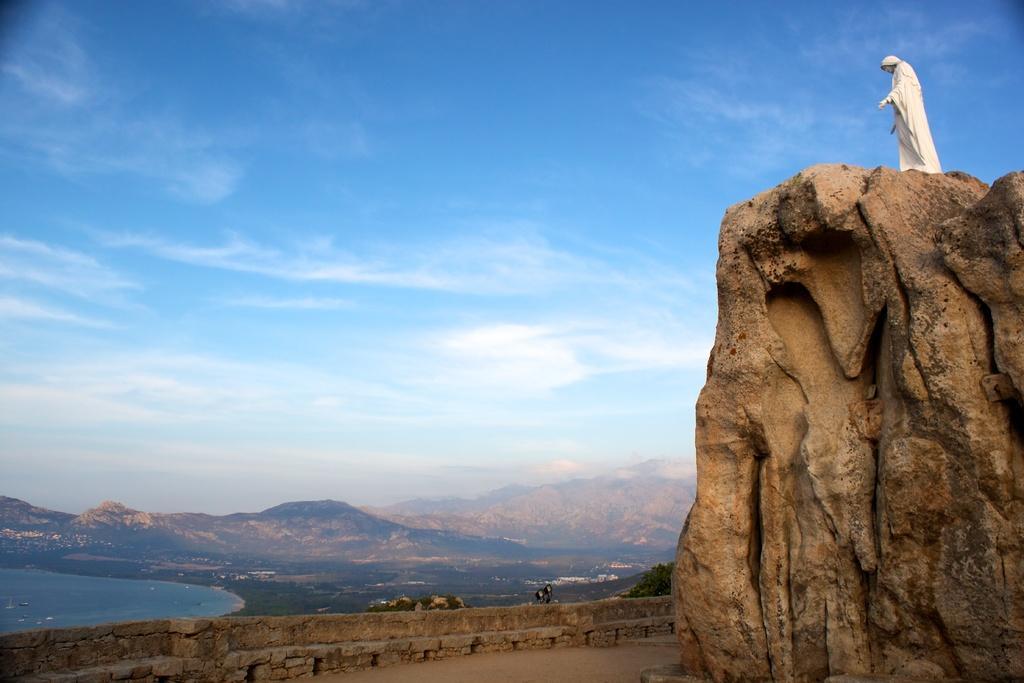Please provide a concise description of this image. In this picture we can see a statue, here we can see rocks, ground, beside this ground we can see a wall, trees and some objects and in the background we can see water and sky with clouds. 